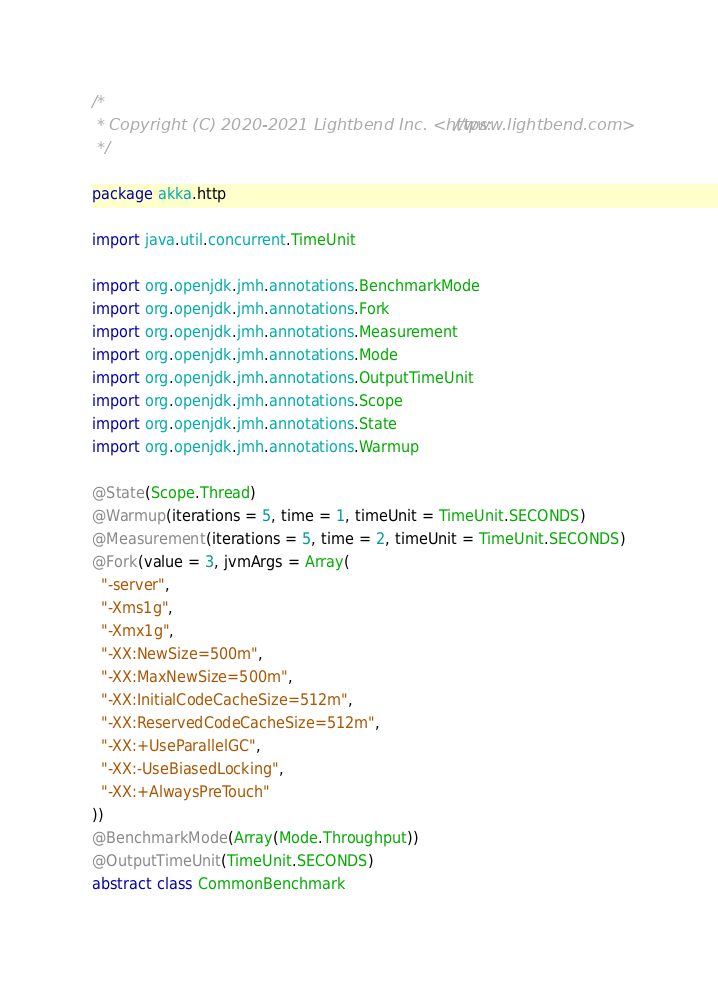<code> <loc_0><loc_0><loc_500><loc_500><_Scala_>/*
 * Copyright (C) 2020-2021 Lightbend Inc. <https://www.lightbend.com>
 */

package akka.http

import java.util.concurrent.TimeUnit

import org.openjdk.jmh.annotations.BenchmarkMode
import org.openjdk.jmh.annotations.Fork
import org.openjdk.jmh.annotations.Measurement
import org.openjdk.jmh.annotations.Mode
import org.openjdk.jmh.annotations.OutputTimeUnit
import org.openjdk.jmh.annotations.Scope
import org.openjdk.jmh.annotations.State
import org.openjdk.jmh.annotations.Warmup

@State(Scope.Thread)
@Warmup(iterations = 5, time = 1, timeUnit = TimeUnit.SECONDS)
@Measurement(iterations = 5, time = 2, timeUnit = TimeUnit.SECONDS)
@Fork(value = 3, jvmArgs = Array(
  "-server",
  "-Xms1g",
  "-Xmx1g",
  "-XX:NewSize=500m",
  "-XX:MaxNewSize=500m",
  "-XX:InitialCodeCacheSize=512m",
  "-XX:ReservedCodeCacheSize=512m",
  "-XX:+UseParallelGC",
  "-XX:-UseBiasedLocking",
  "-XX:+AlwaysPreTouch"
))
@BenchmarkMode(Array(Mode.Throughput))
@OutputTimeUnit(TimeUnit.SECONDS)
abstract class CommonBenchmark
</code> 